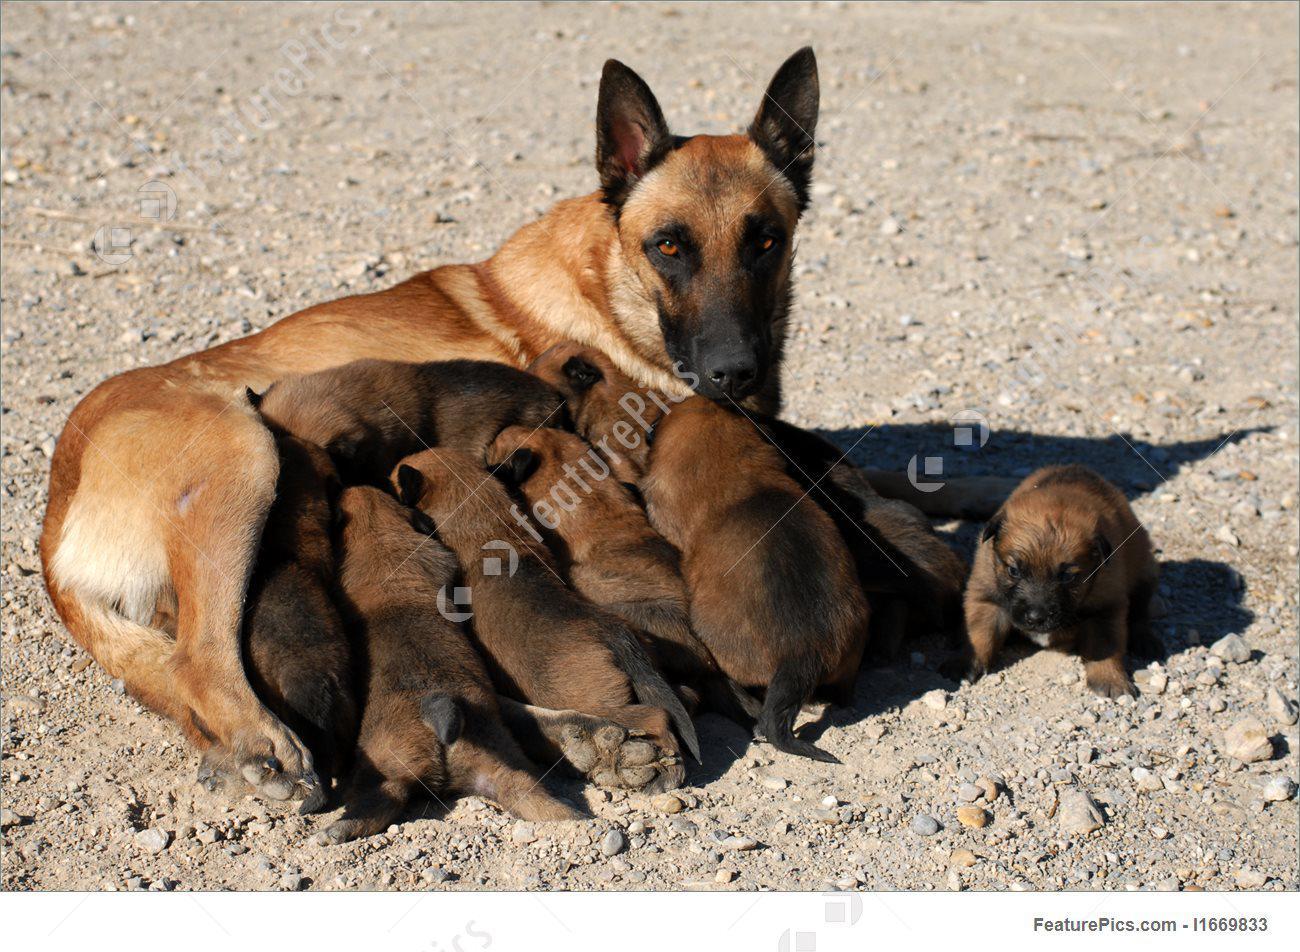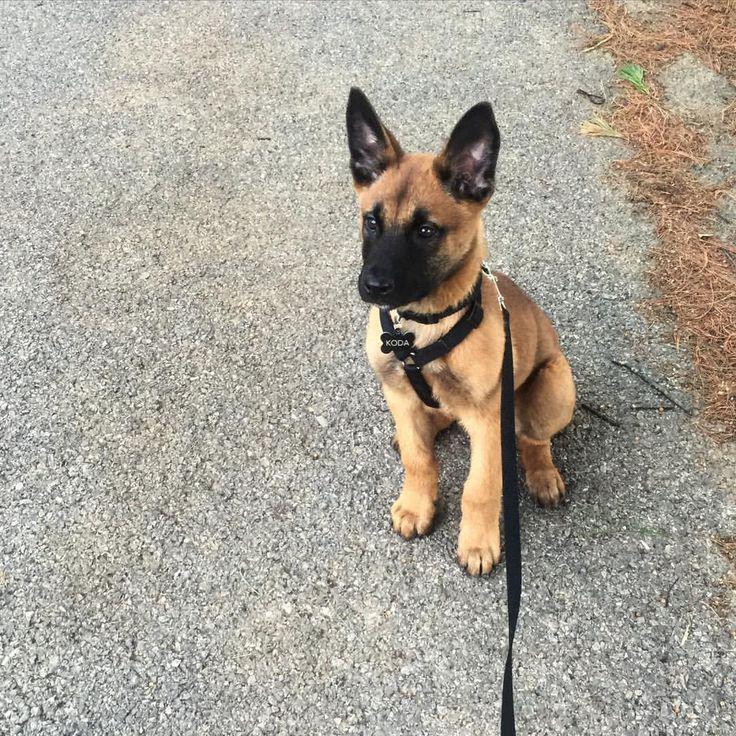The first image is the image on the left, the second image is the image on the right. Considering the images on both sides, is "One of the dogs is wearing a black collar." valid? Answer yes or no. Yes. 